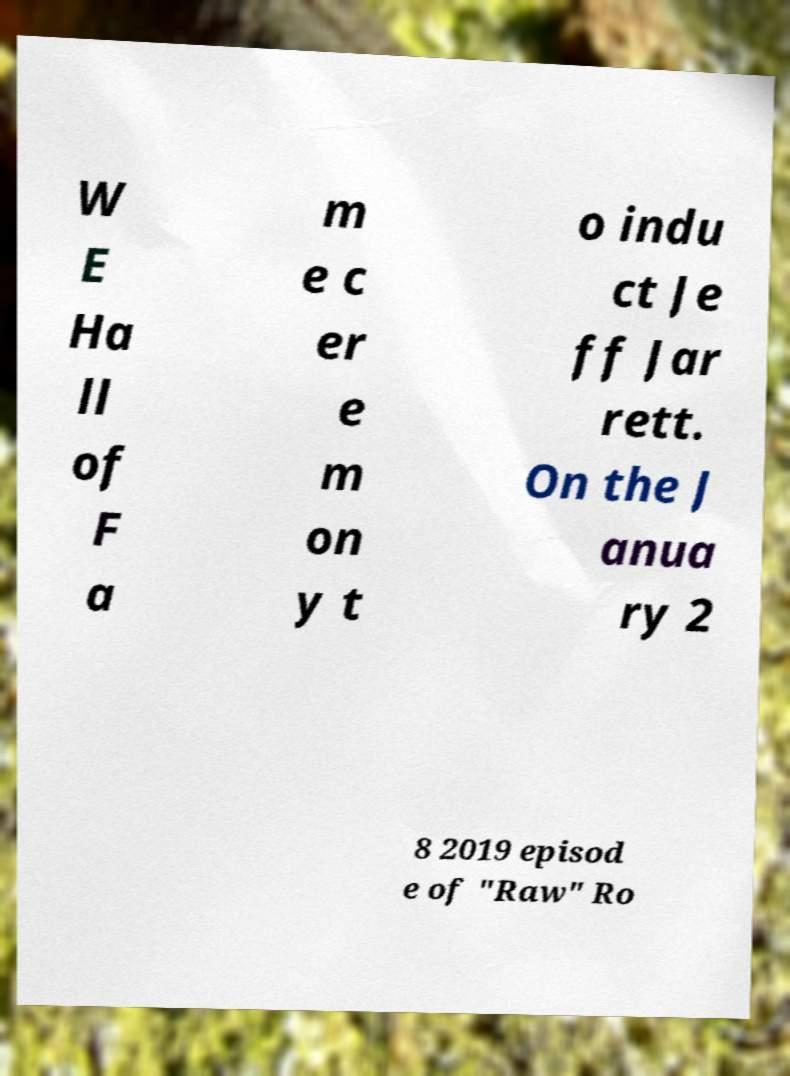There's text embedded in this image that I need extracted. Can you transcribe it verbatim? W E Ha ll of F a m e c er e m on y t o indu ct Je ff Jar rett. On the J anua ry 2 8 2019 episod e of "Raw" Ro 